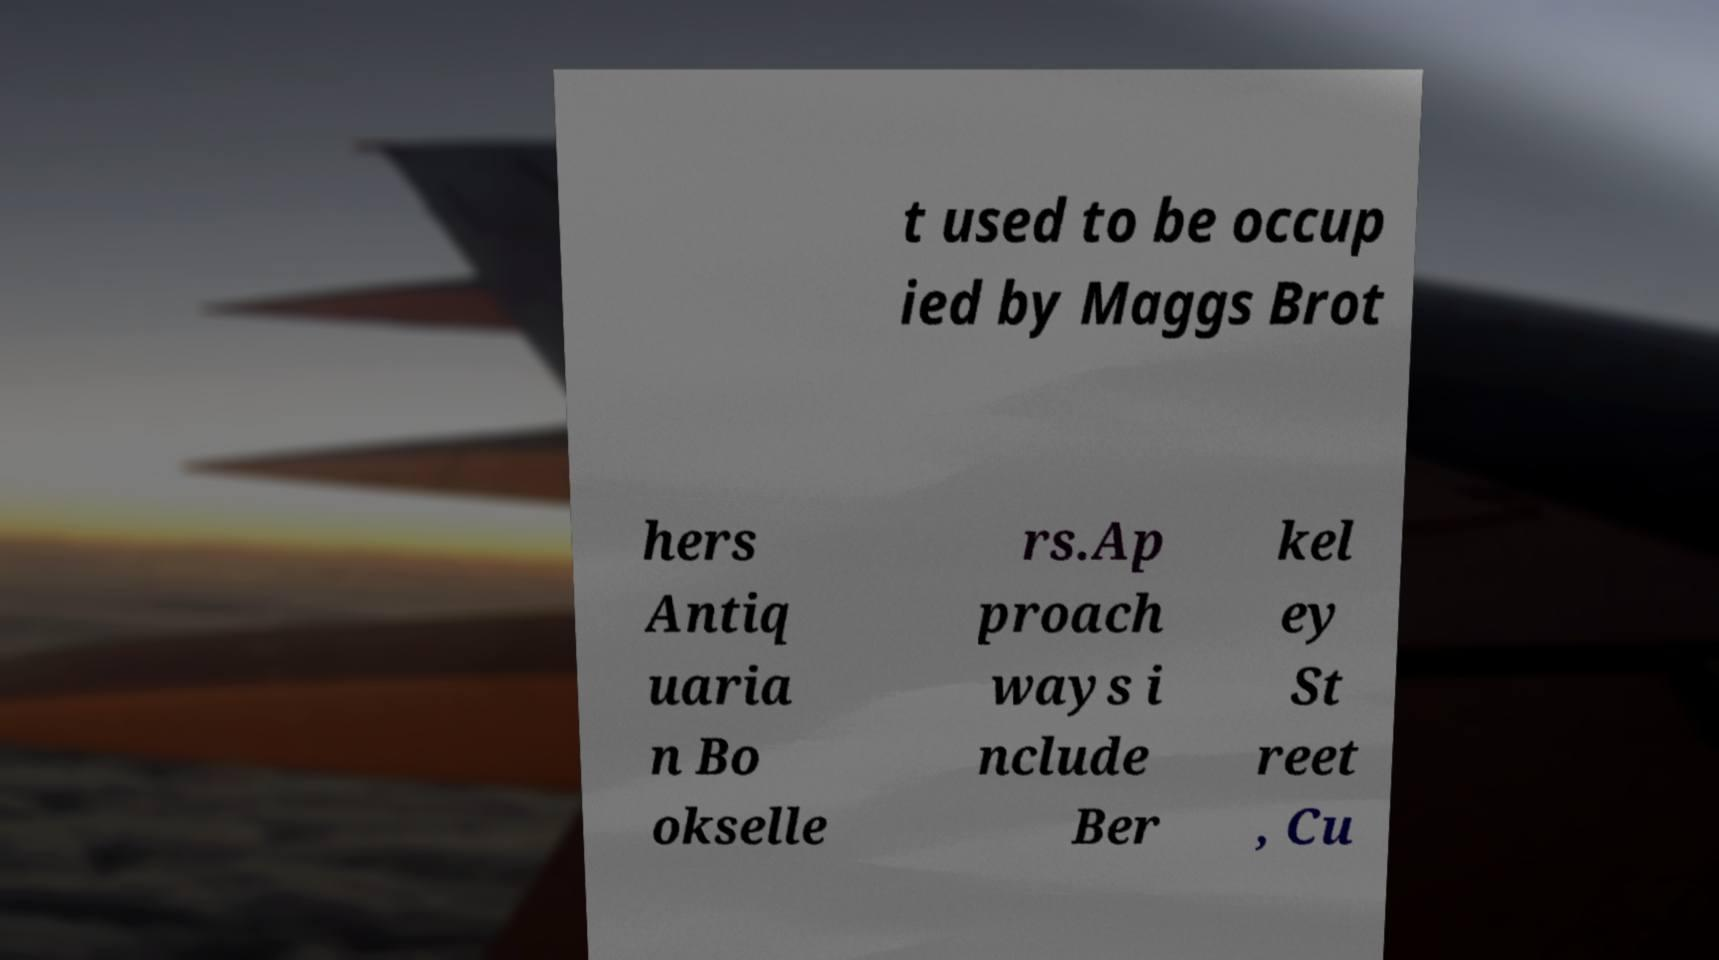Could you assist in decoding the text presented in this image and type it out clearly? t used to be occup ied by Maggs Brot hers Antiq uaria n Bo okselle rs.Ap proach ways i nclude Ber kel ey St reet , Cu 